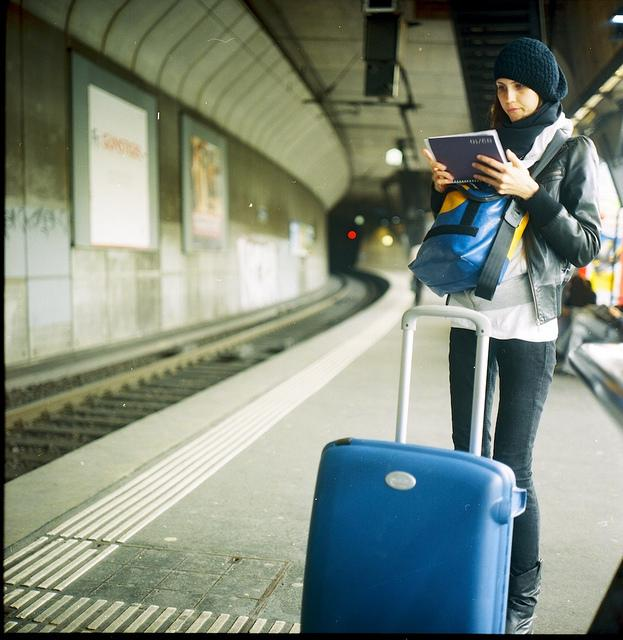What is the best luggage brand in the world? Please explain your reasoning. away. The question is subjective, but answer d is commonly regarded as one of the most widely used and preferred brands. 